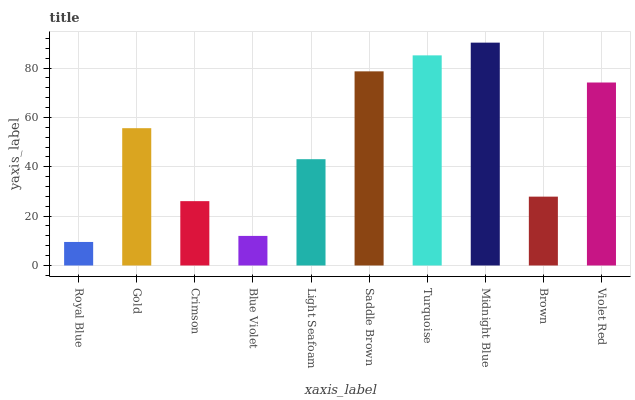Is Royal Blue the minimum?
Answer yes or no. Yes. Is Midnight Blue the maximum?
Answer yes or no. Yes. Is Gold the minimum?
Answer yes or no. No. Is Gold the maximum?
Answer yes or no. No. Is Gold greater than Royal Blue?
Answer yes or no. Yes. Is Royal Blue less than Gold?
Answer yes or no. Yes. Is Royal Blue greater than Gold?
Answer yes or no. No. Is Gold less than Royal Blue?
Answer yes or no. No. Is Gold the high median?
Answer yes or no. Yes. Is Light Seafoam the low median?
Answer yes or no. Yes. Is Crimson the high median?
Answer yes or no. No. Is Royal Blue the low median?
Answer yes or no. No. 